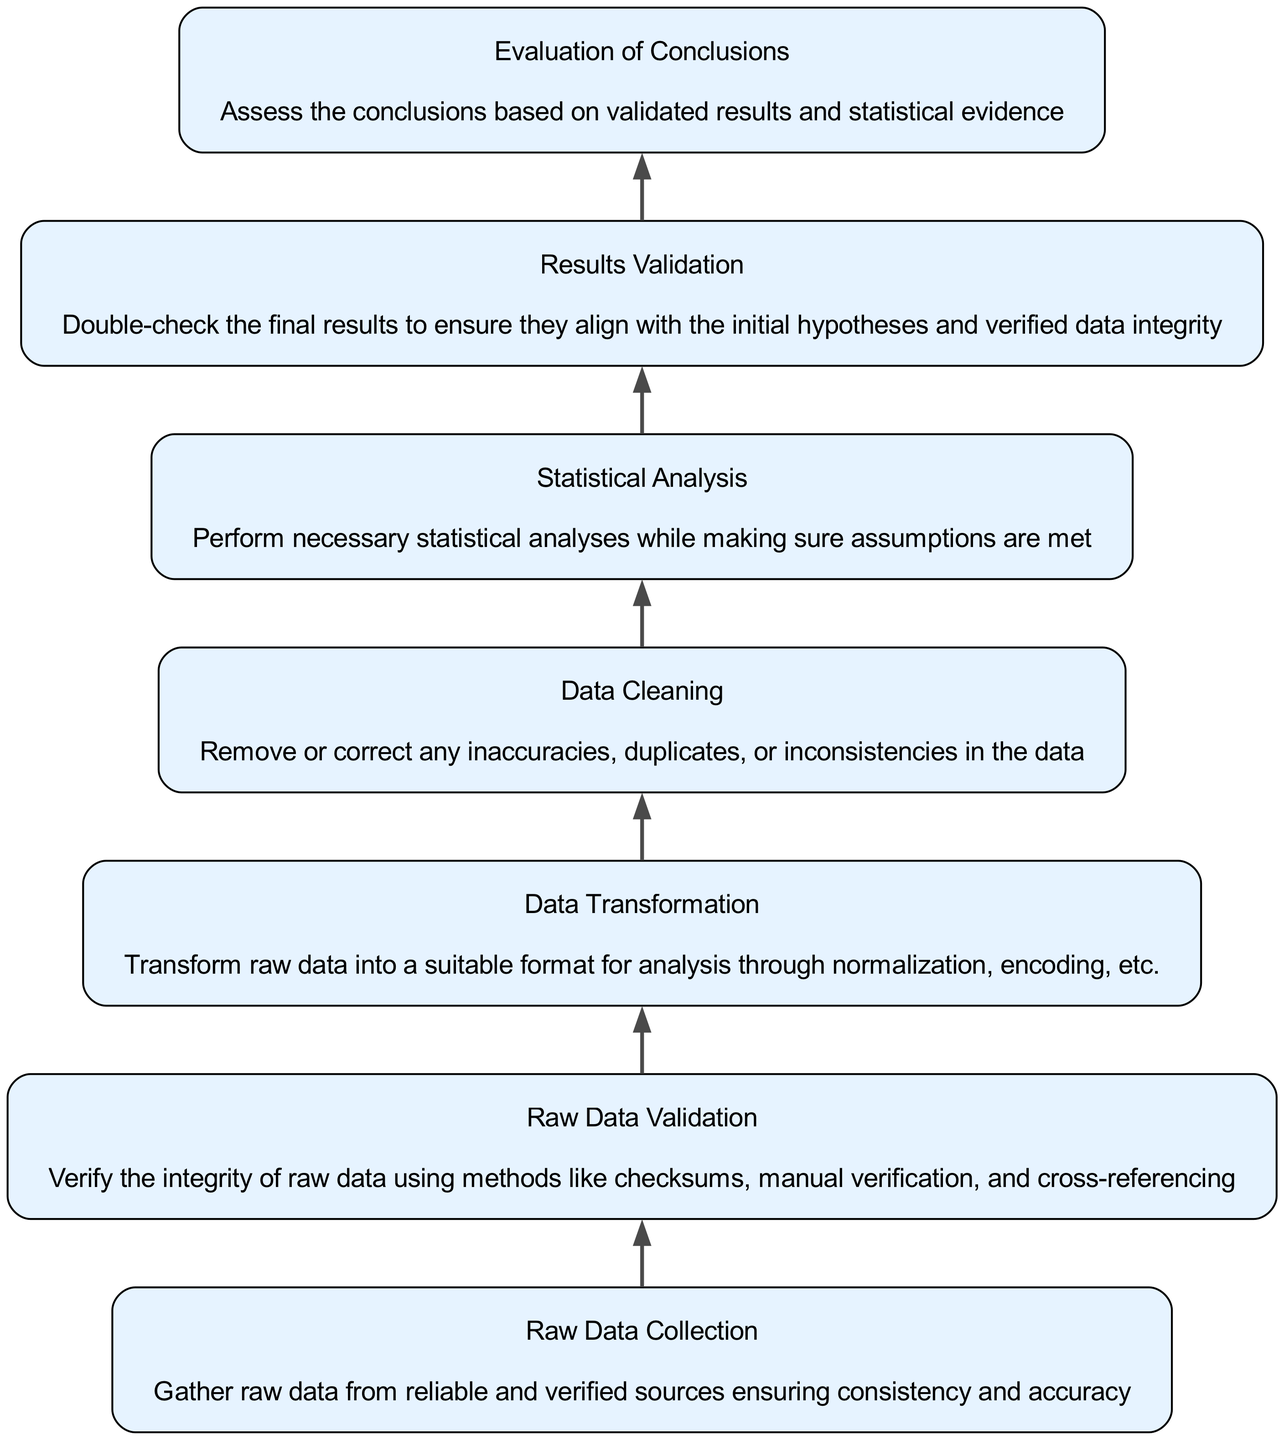What is the last step in the flow chart? The last step is "Evaluation of Conclusions," which is at the top of the diagram and signifies that conclusions are formed following the rest of the analysis steps.
Answer: Evaluation of Conclusions How many elements are there in the diagram? There are six elements in the diagram representing various stages in verifying data integrity, starting from raw data collection to final conclusions.
Answer: Six Which element directly follows "Statistical Analysis"? "Results Validation" directly follows "Statistical Analysis" as indicated by the flow direction of the diagram from bottom to top.
Answer: Results Validation What dependencies does "Data Transformation" have? "Data Transformation" depends on "Raw Data Validation," meaning it cannot occur until raw data integrity has been verified.
Answer: Raw Data Validation Which node indicates the verification of raw data integrity? The node "Raw Data Validation" is specifically responsible for verifying the integrity of the raw data collected, ensuring that the data is accurate and reliable.
Answer: Raw Data Validation How does one arrive at "Evaluation of Conclusions"? To reach "Evaluation of Conclusions," one must first complete "Results Validation," followed by "Statistical Analysis," moving up through the flow of the diagram. This indicates a cascade of validation leading to conclusions.
Answer: Through validation results and statistical analysis What initial action is shown at the bottom of the flow chart? The initial action is "Raw Data Collection," which signifies the starting point for gathering data needed for the subsequent integrity verification steps.
Answer: Raw Data Collection Which element is most critical for ensuring data accuracy? "Data Cleaning" is critical for ensuring data accuracy as it focuses on correcting inaccuracies within the dataset before further analysis can take place.
Answer: Data Cleaning Identify the relationship between "Data Cleaning" and "Statistical Analysis." "Data Cleaning" must occur before "Statistical Analysis" can take place, as the analysis relies on cleaned and accurate data to yield valid results.
Answer: Data Cleaning precedes Statistical Analysis 